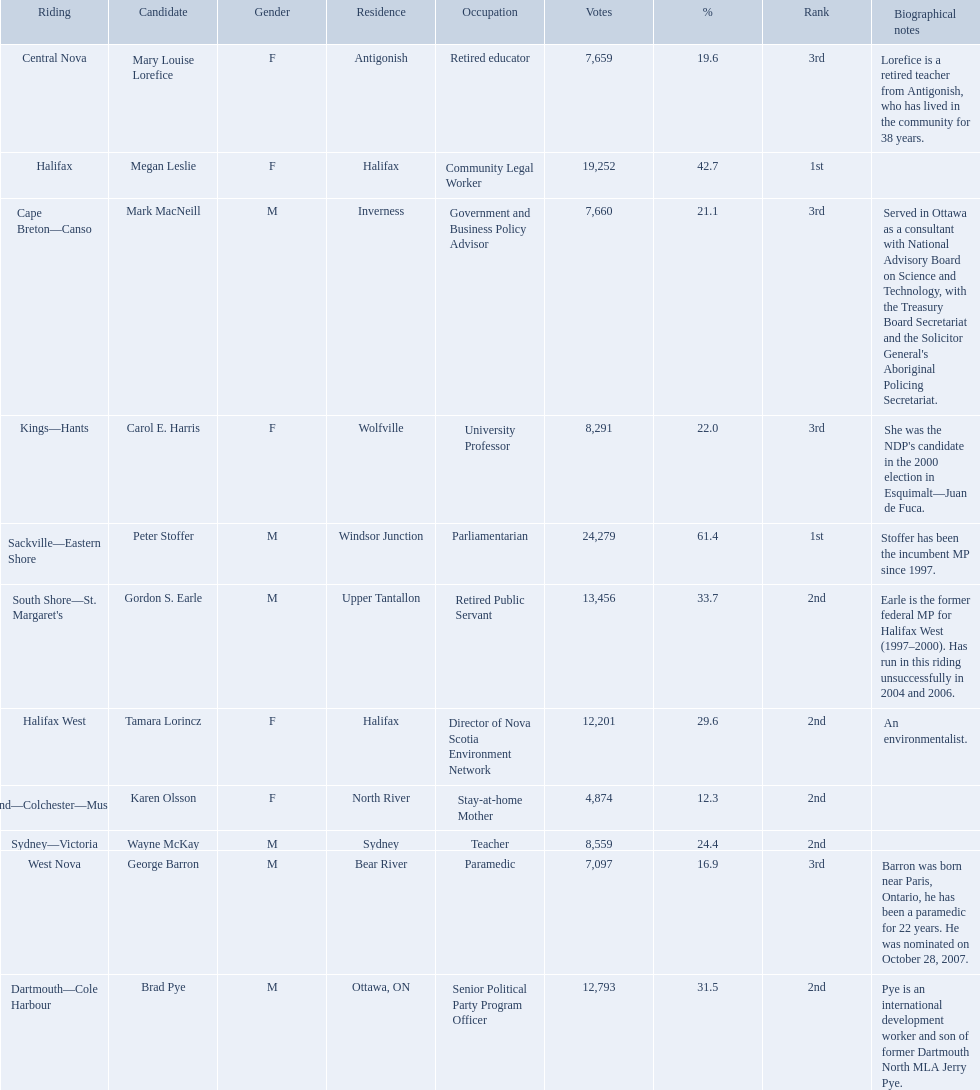Which candidates have the four lowest amount of votes Mark MacNeill, Mary Louise Lorefice, Karen Olsson, George Barron. Out of the following, who has the third most? Mark MacNeill. 